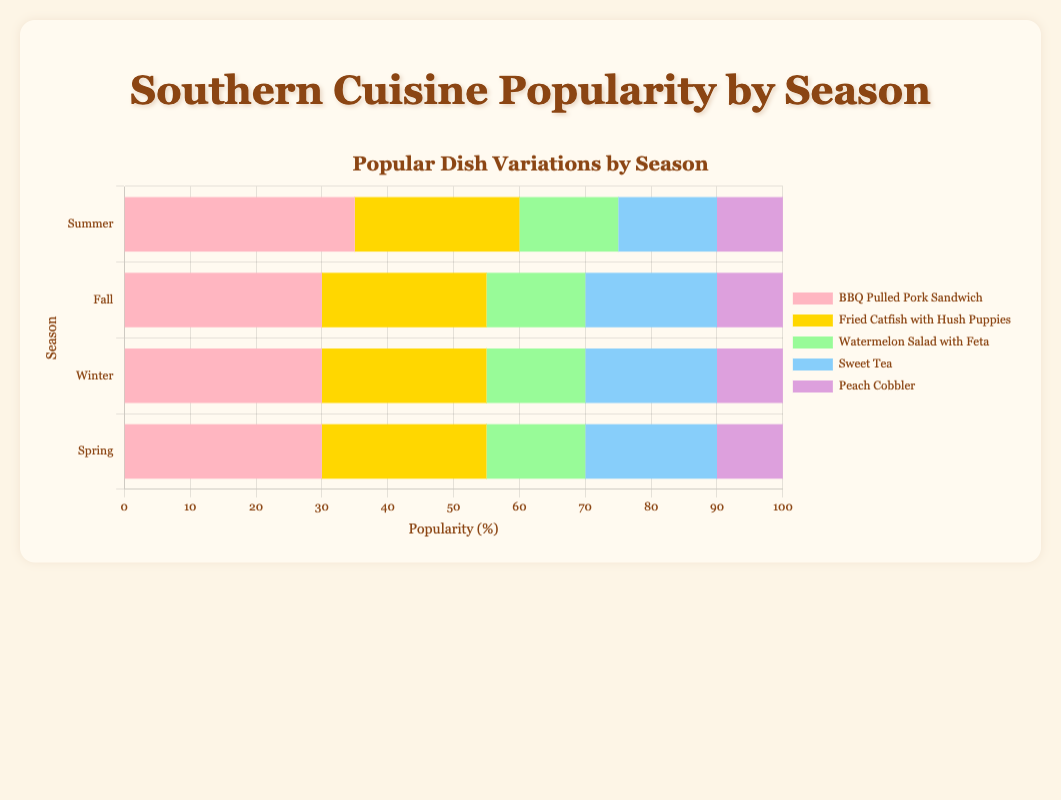What's the most popular dish in Summer? Looking at the dataset for Summer, the BBQ Pulled Pork Sandwich has the highest popularity score of 35.
Answer: BBQ Pulled Pork Sandwich Which season has the highest popularity for Cornbread? By comparing the availability of Cornbread across seasons, it is only listed in Fall with a popularity score of 20.
Answer: Fall What is the difference in popularity between Fried Chicken in Winter and Chicken and Dumplings in Fall? In Winter, Fried Chicken has a popularity of 30. In Fall, Chicken and Dumplings have a popularity of 25. The difference is 30 - 25 = 5.
Answer: 5 What dish has the lowest popularity in Spring? For Spring, the dish with the lowest popularity score is Key Lime Pie with a score of 10.
Answer: Key Lime Pie Compare the popularity of Sweet Tea in Summer to Hot Cocoa in Winter. Sweet Tea in Summer has a popularity score of 15, and Hot Cocoa in Winter also has a score of 10. Therefore, Sweet Tea is more popular.
Answer: Sweet Tea Which dish's popularity stays the same across different seasons? By observing the data, no dish appears in multiple seasons with the same popularity score, so all dishes listed have varying popularity.
Answer: None What is the total popularity score of the top 3 dishes in Fall? The top three dishes in Fall are Gumbo (30), Chicken and Dumplings (25), and Cornbread (20). Summing these scores gives 30 + 25 + 20 = 75.
Answer: 75 Identify which season has the highest cumulative popularity score. Summing up the popularity scores for each season: 
- Summer: 35 + 25 + 15 + 15 + 10 = 100
- Fall: 30 + 25 + 20 + 15 + 10 = 100
- Winter: 30 + 25 + 20 + 15 + 10 = 100
- Spring: 30 + 25 + 20 + 15 + 10 = 100
Each season has a total score of 100, so they are equal.
Answer: All seasons have equal popularity What is the average popularity score of dishes in Winter? Adding up the popularity scores for Winter (30 + 25 + 20 + 15 + 10) gives a total of 100. Dividing by 5 dishes gives an average score of 20.
Answer: 20 